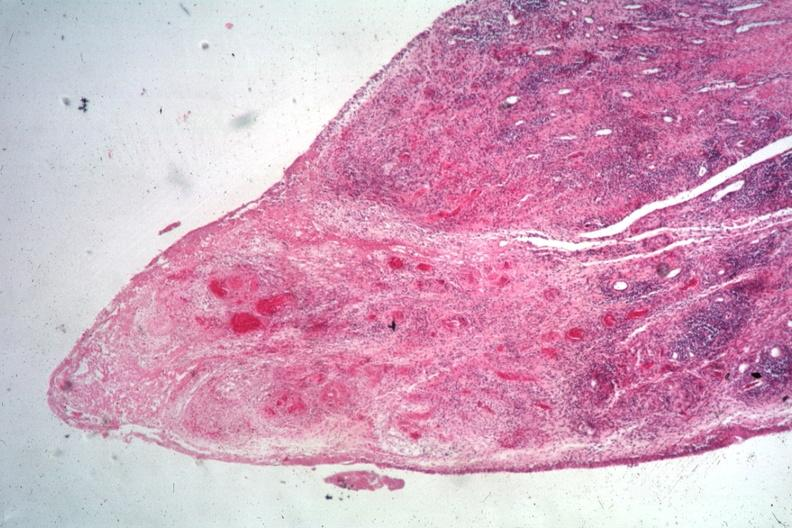how is typical lesion case associated with vasculitis?
Answer the question using a single word or phrase. Widespread 